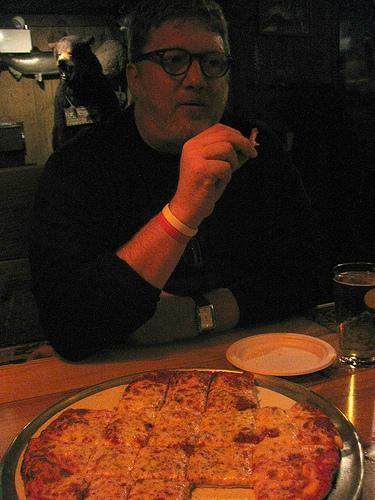How many plates are on the counter?
Give a very brief answer. 1. How many bracelets are on the man's wrist?
Give a very brief answer. 2. 